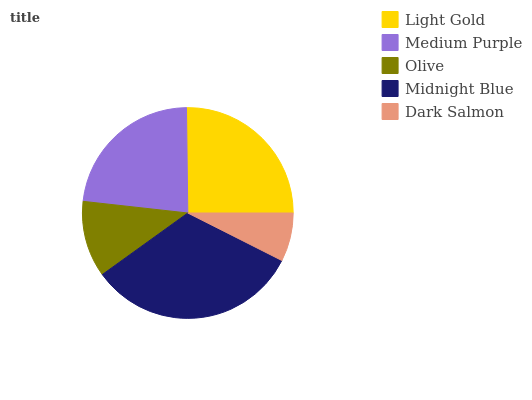Is Dark Salmon the minimum?
Answer yes or no. Yes. Is Midnight Blue the maximum?
Answer yes or no. Yes. Is Medium Purple the minimum?
Answer yes or no. No. Is Medium Purple the maximum?
Answer yes or no. No. Is Light Gold greater than Medium Purple?
Answer yes or no. Yes. Is Medium Purple less than Light Gold?
Answer yes or no. Yes. Is Medium Purple greater than Light Gold?
Answer yes or no. No. Is Light Gold less than Medium Purple?
Answer yes or no. No. Is Medium Purple the high median?
Answer yes or no. Yes. Is Medium Purple the low median?
Answer yes or no. Yes. Is Midnight Blue the high median?
Answer yes or no. No. Is Midnight Blue the low median?
Answer yes or no. No. 